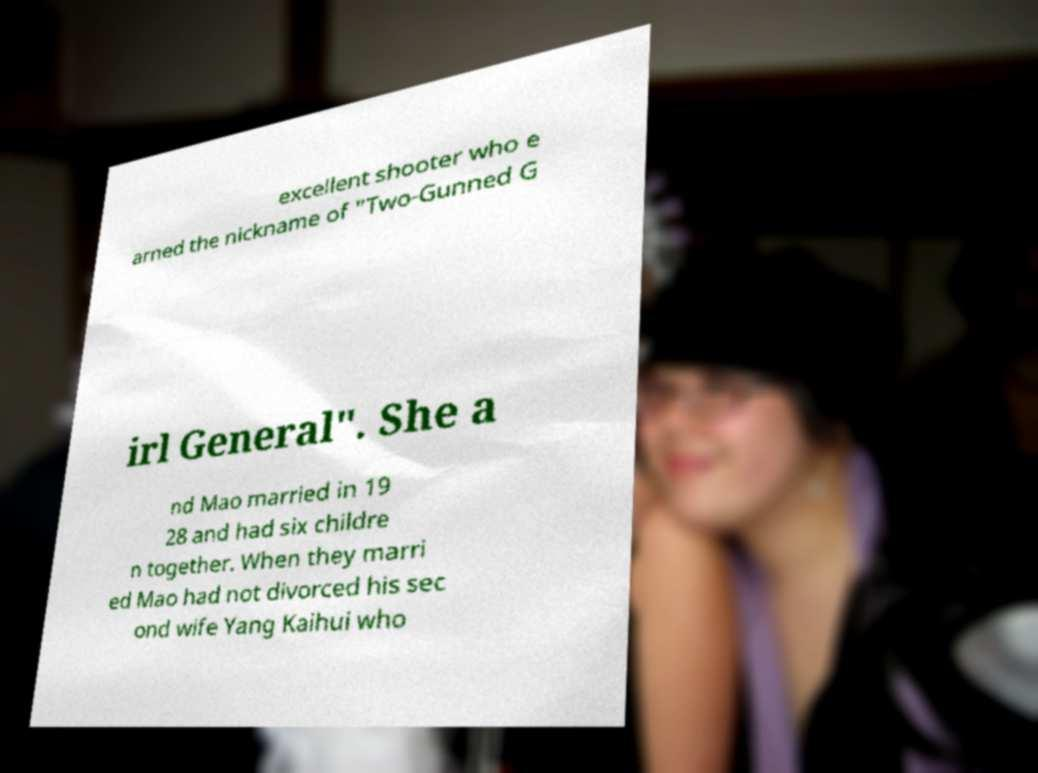What messages or text are displayed in this image? I need them in a readable, typed format. excellent shooter who e arned the nickname of "Two-Gunned G irl General". She a nd Mao married in 19 28 and had six childre n together. When they marri ed Mao had not divorced his sec ond wife Yang Kaihui who 